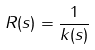<formula> <loc_0><loc_0><loc_500><loc_500>R ( s ) = \frac { 1 } { k ( s ) }</formula> 